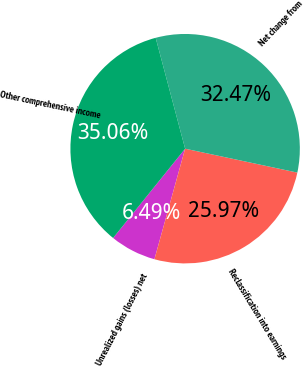Convert chart. <chart><loc_0><loc_0><loc_500><loc_500><pie_chart><fcel>Unrealized gains (losses) net<fcel>Reclassification into earnings<fcel>Net change from<fcel>Other comprehensive income<nl><fcel>6.49%<fcel>25.97%<fcel>32.47%<fcel>35.06%<nl></chart> 